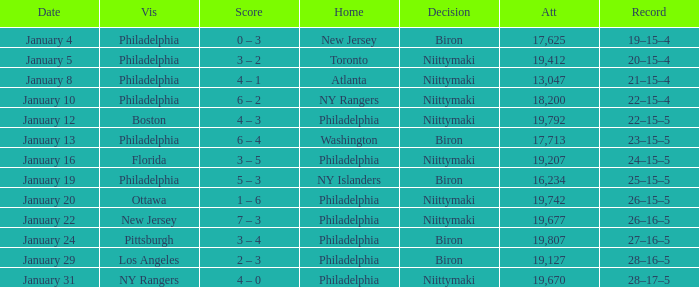What was the date that the decision was Niittymaki, the attendance larger than 19,207, and the record 28–17–5? January 31. 